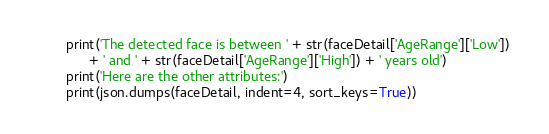Convert code to text. <code><loc_0><loc_0><loc_500><loc_500><_Python_>        print('The detected face is between ' + str(faceDetail['AgeRange']['Low']) 
              + ' and ' + str(faceDetail['AgeRange']['High']) + ' years old')
        print('Here are the other attributes:')
        print(json.dumps(faceDetail, indent=4, sort_keys=True))</code> 